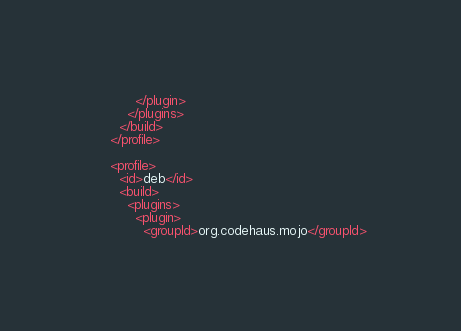<code> <loc_0><loc_0><loc_500><loc_500><_XML_>          </plugin>
        </plugins>
      </build>
    </profile>

    <profile>
      <id>deb</id>
      <build>
        <plugins>
          <plugin>
            <groupId>org.codehaus.mojo</groupId></code> 